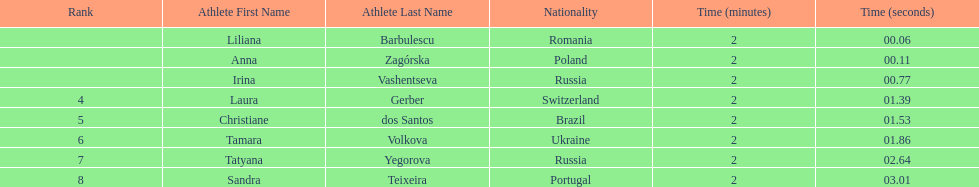Who were the athletes? Liliana Barbulescu, 2:00.06, Anna Zagórska, 2:00.11, Irina Vashentseva, 2:00.77, Laura Gerber, 2:01.39, Christiane dos Santos, 2:01.53, Tamara Volkova, 2:01.86, Tatyana Yegorova, 2:02.64, Sandra Teixeira, 2:03.01. Who received 2nd place? Anna Zagórska, 2:00.11. What was her time? 2:00.11. Give me the full table as a dictionary. {'header': ['Rank', 'Athlete First Name', 'Athlete Last Name', 'Nationality', 'Time (minutes)', 'Time (seconds)'], 'rows': [['', 'Liliana', 'Barbulescu', 'Romania', '2', '00.06'], ['', 'Anna', 'Zagórska', 'Poland', '2', '00.11'], ['', 'Irina', 'Vashentseva', 'Russia', '2', '00.77'], ['4', 'Laura', 'Gerber', 'Switzerland', '2', '01.39'], ['5', 'Christiane', 'dos Santos', 'Brazil', '2', '01.53'], ['6', 'Tamara', 'Volkova', 'Ukraine', '2', '01.86'], ['7', 'Tatyana', 'Yegorova', 'Russia', '2', '02.64'], ['8', 'Sandra', 'Teixeira', 'Portugal', '2', '03.01']]} 